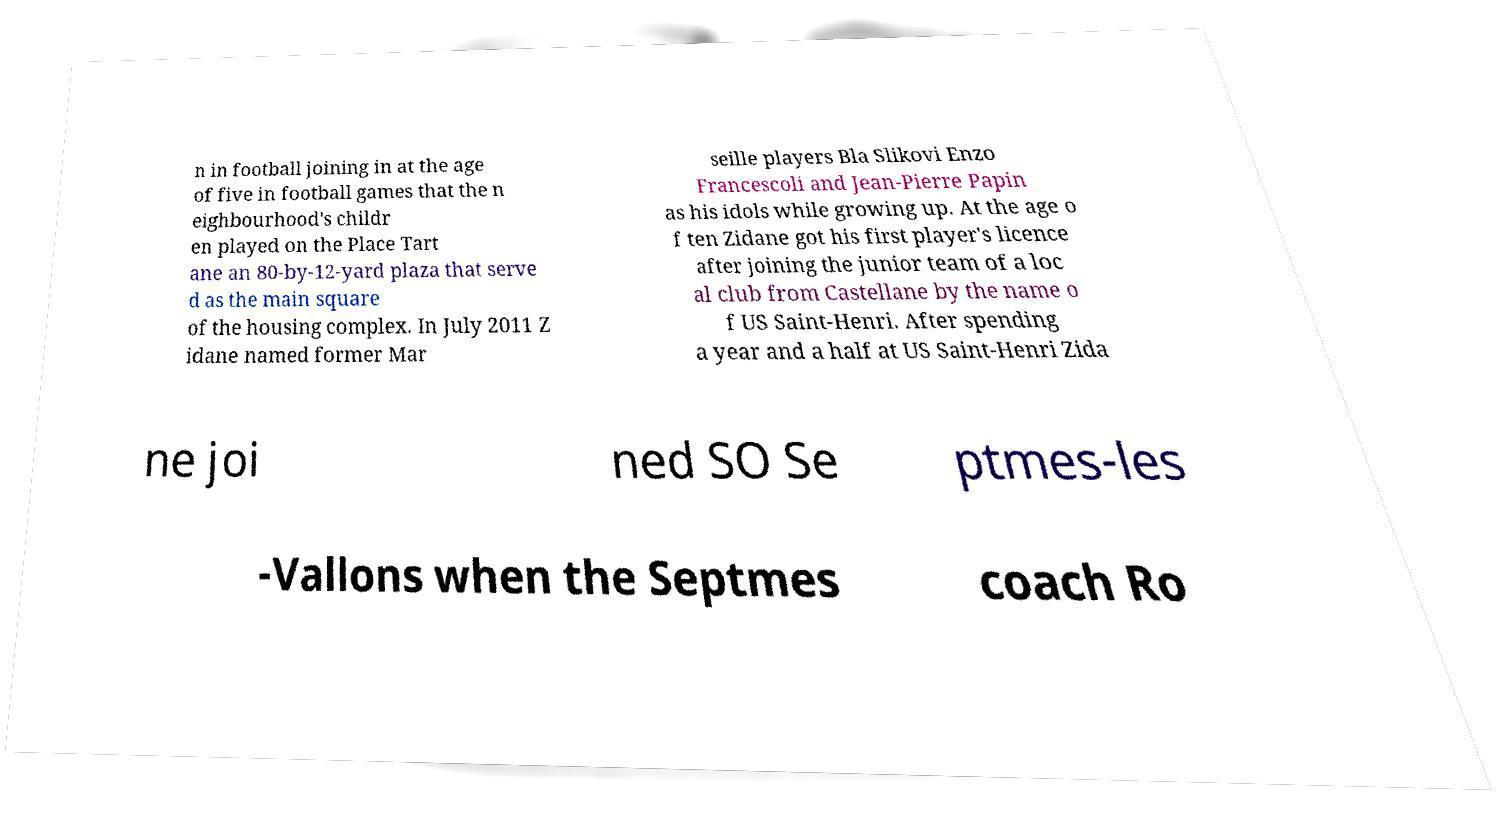I need the written content from this picture converted into text. Can you do that? n in football joining in at the age of five in football games that the n eighbourhood's childr en played on the Place Tart ane an 80-by-12-yard plaza that serve d as the main square of the housing complex. In July 2011 Z idane named former Mar seille players Bla Slikovi Enzo Francescoli and Jean-Pierre Papin as his idols while growing up. At the age o f ten Zidane got his first player's licence after joining the junior team of a loc al club from Castellane by the name o f US Saint-Henri. After spending a year and a half at US Saint-Henri Zida ne joi ned SO Se ptmes-les -Vallons when the Septmes coach Ro 